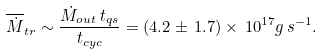Convert formula to latex. <formula><loc_0><loc_0><loc_500><loc_500>\overline { \dot { M } } _ { t r } \sim \frac { \dot { M } _ { o u t } \, t _ { q s } } { t _ { c y c } } = ( 4 . 2 \pm \, 1 . 7 ) \times \, 1 0 ^ { 1 7 } g \, s ^ { - 1 } .</formula> 